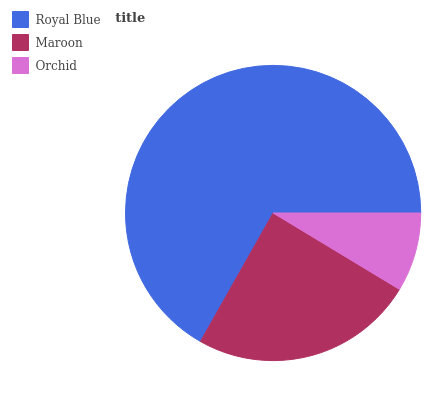Is Orchid the minimum?
Answer yes or no. Yes. Is Royal Blue the maximum?
Answer yes or no. Yes. Is Maroon the minimum?
Answer yes or no. No. Is Maroon the maximum?
Answer yes or no. No. Is Royal Blue greater than Maroon?
Answer yes or no. Yes. Is Maroon less than Royal Blue?
Answer yes or no. Yes. Is Maroon greater than Royal Blue?
Answer yes or no. No. Is Royal Blue less than Maroon?
Answer yes or no. No. Is Maroon the high median?
Answer yes or no. Yes. Is Maroon the low median?
Answer yes or no. Yes. Is Orchid the high median?
Answer yes or no. No. Is Royal Blue the low median?
Answer yes or no. No. 